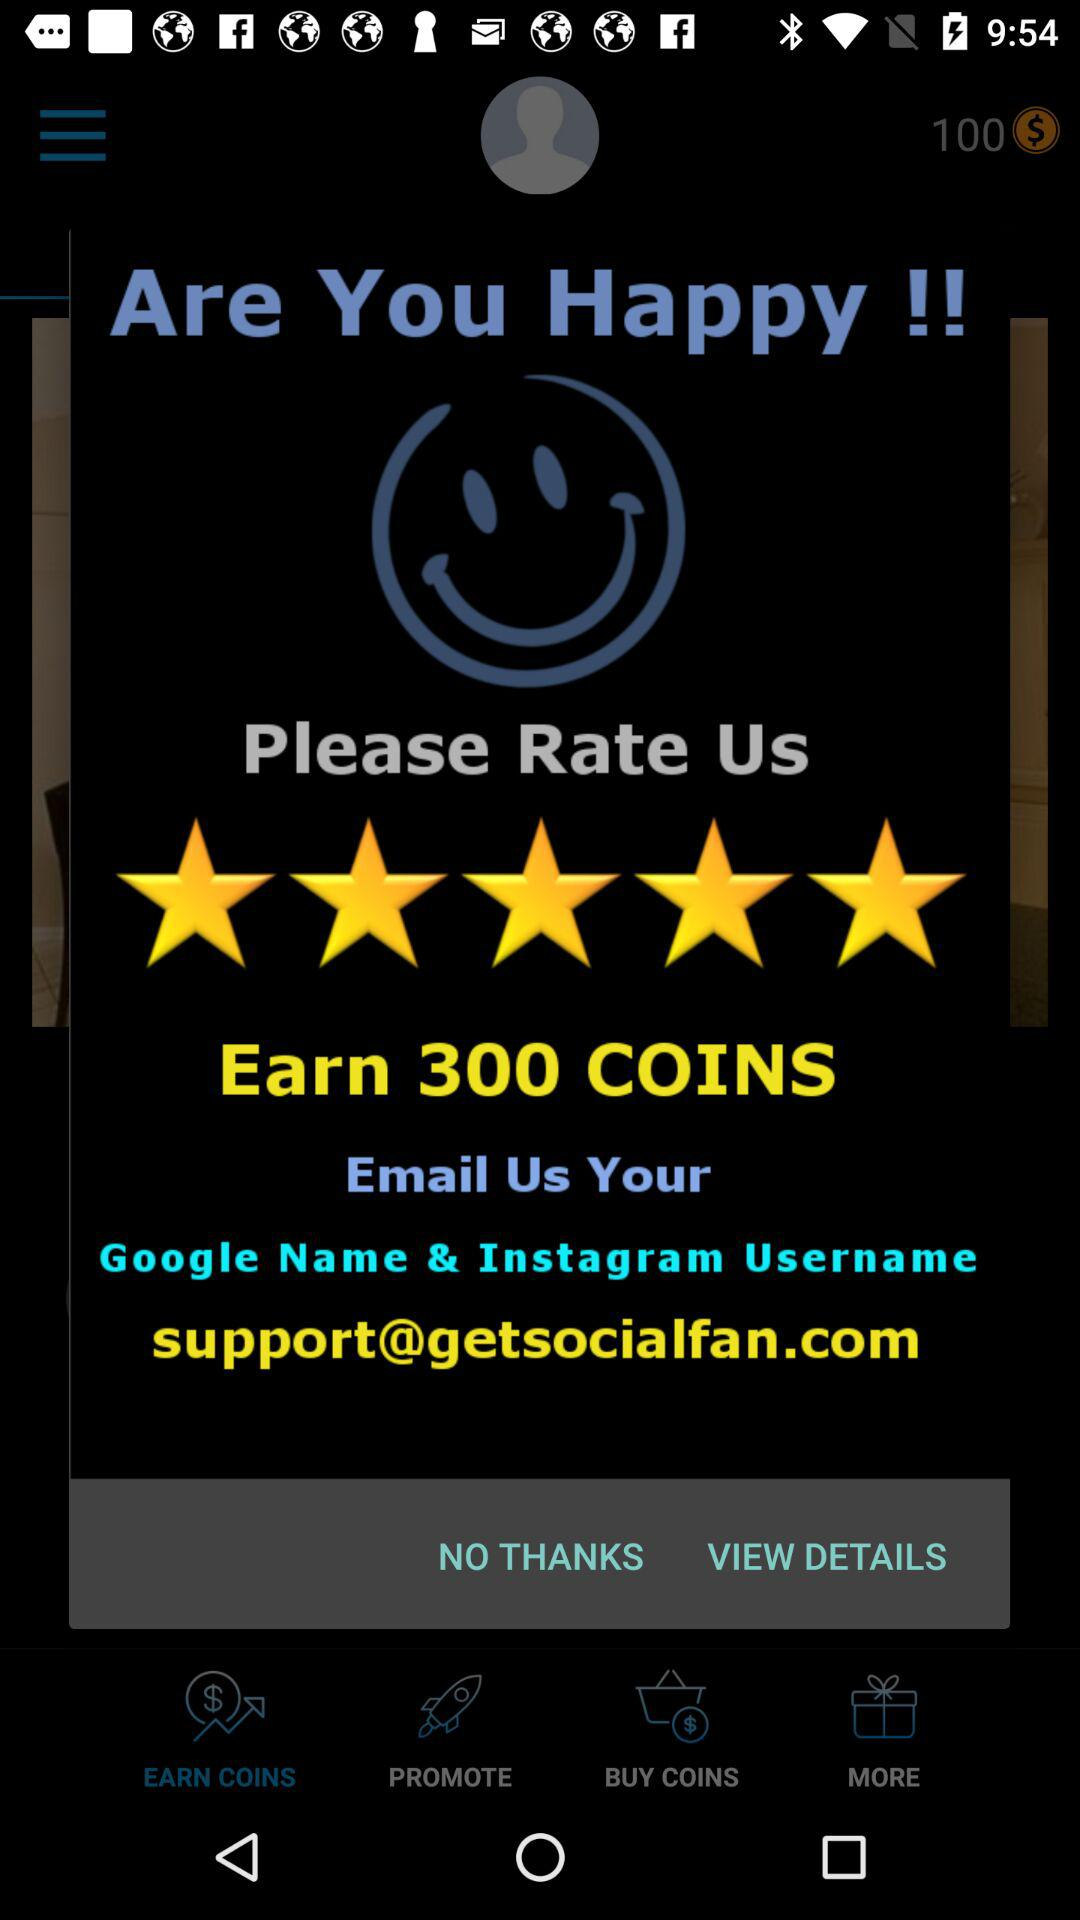What are the ratings and email ID given? The ratings are 5 stars, and the email ID is support@getsocialfan.com. 